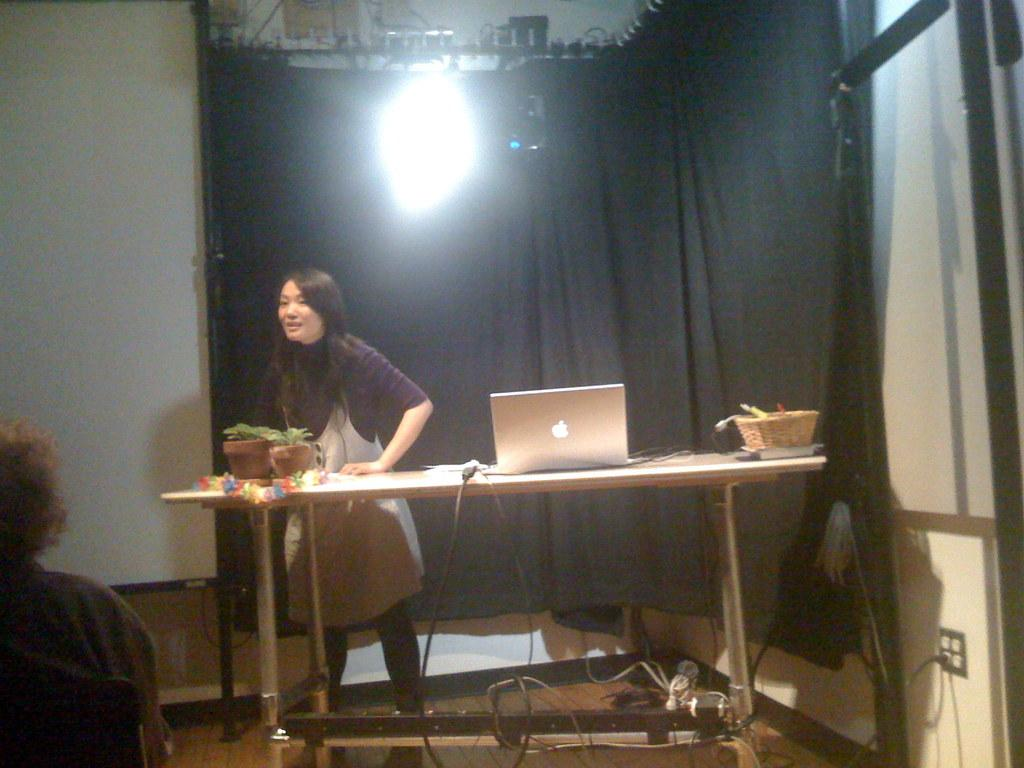Who is present in the image? There is a woman in the image. What is the woman doing in the image? The woman is standing in the image. What objects can be seen on the table in the image? There is a laptop and a basket on the table in the image. What type of goldfish can be seen swimming in the basket on the table? There is no goldfish present in the image; the basket on the table is empty. 